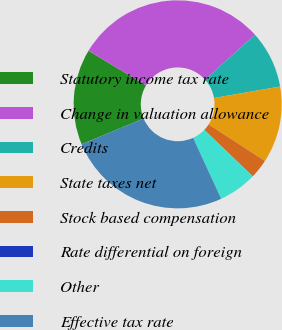Convert chart. <chart><loc_0><loc_0><loc_500><loc_500><pie_chart><fcel>Statutory income tax rate<fcel>Change in valuation allowance<fcel>Credits<fcel>State taxes net<fcel>Stock based compensation<fcel>Rate differential on foreign<fcel>Other<fcel>Effective tax rate<nl><fcel>14.87%<fcel>29.73%<fcel>8.93%<fcel>11.9%<fcel>2.99%<fcel>0.02%<fcel>5.96%<fcel>25.6%<nl></chart> 